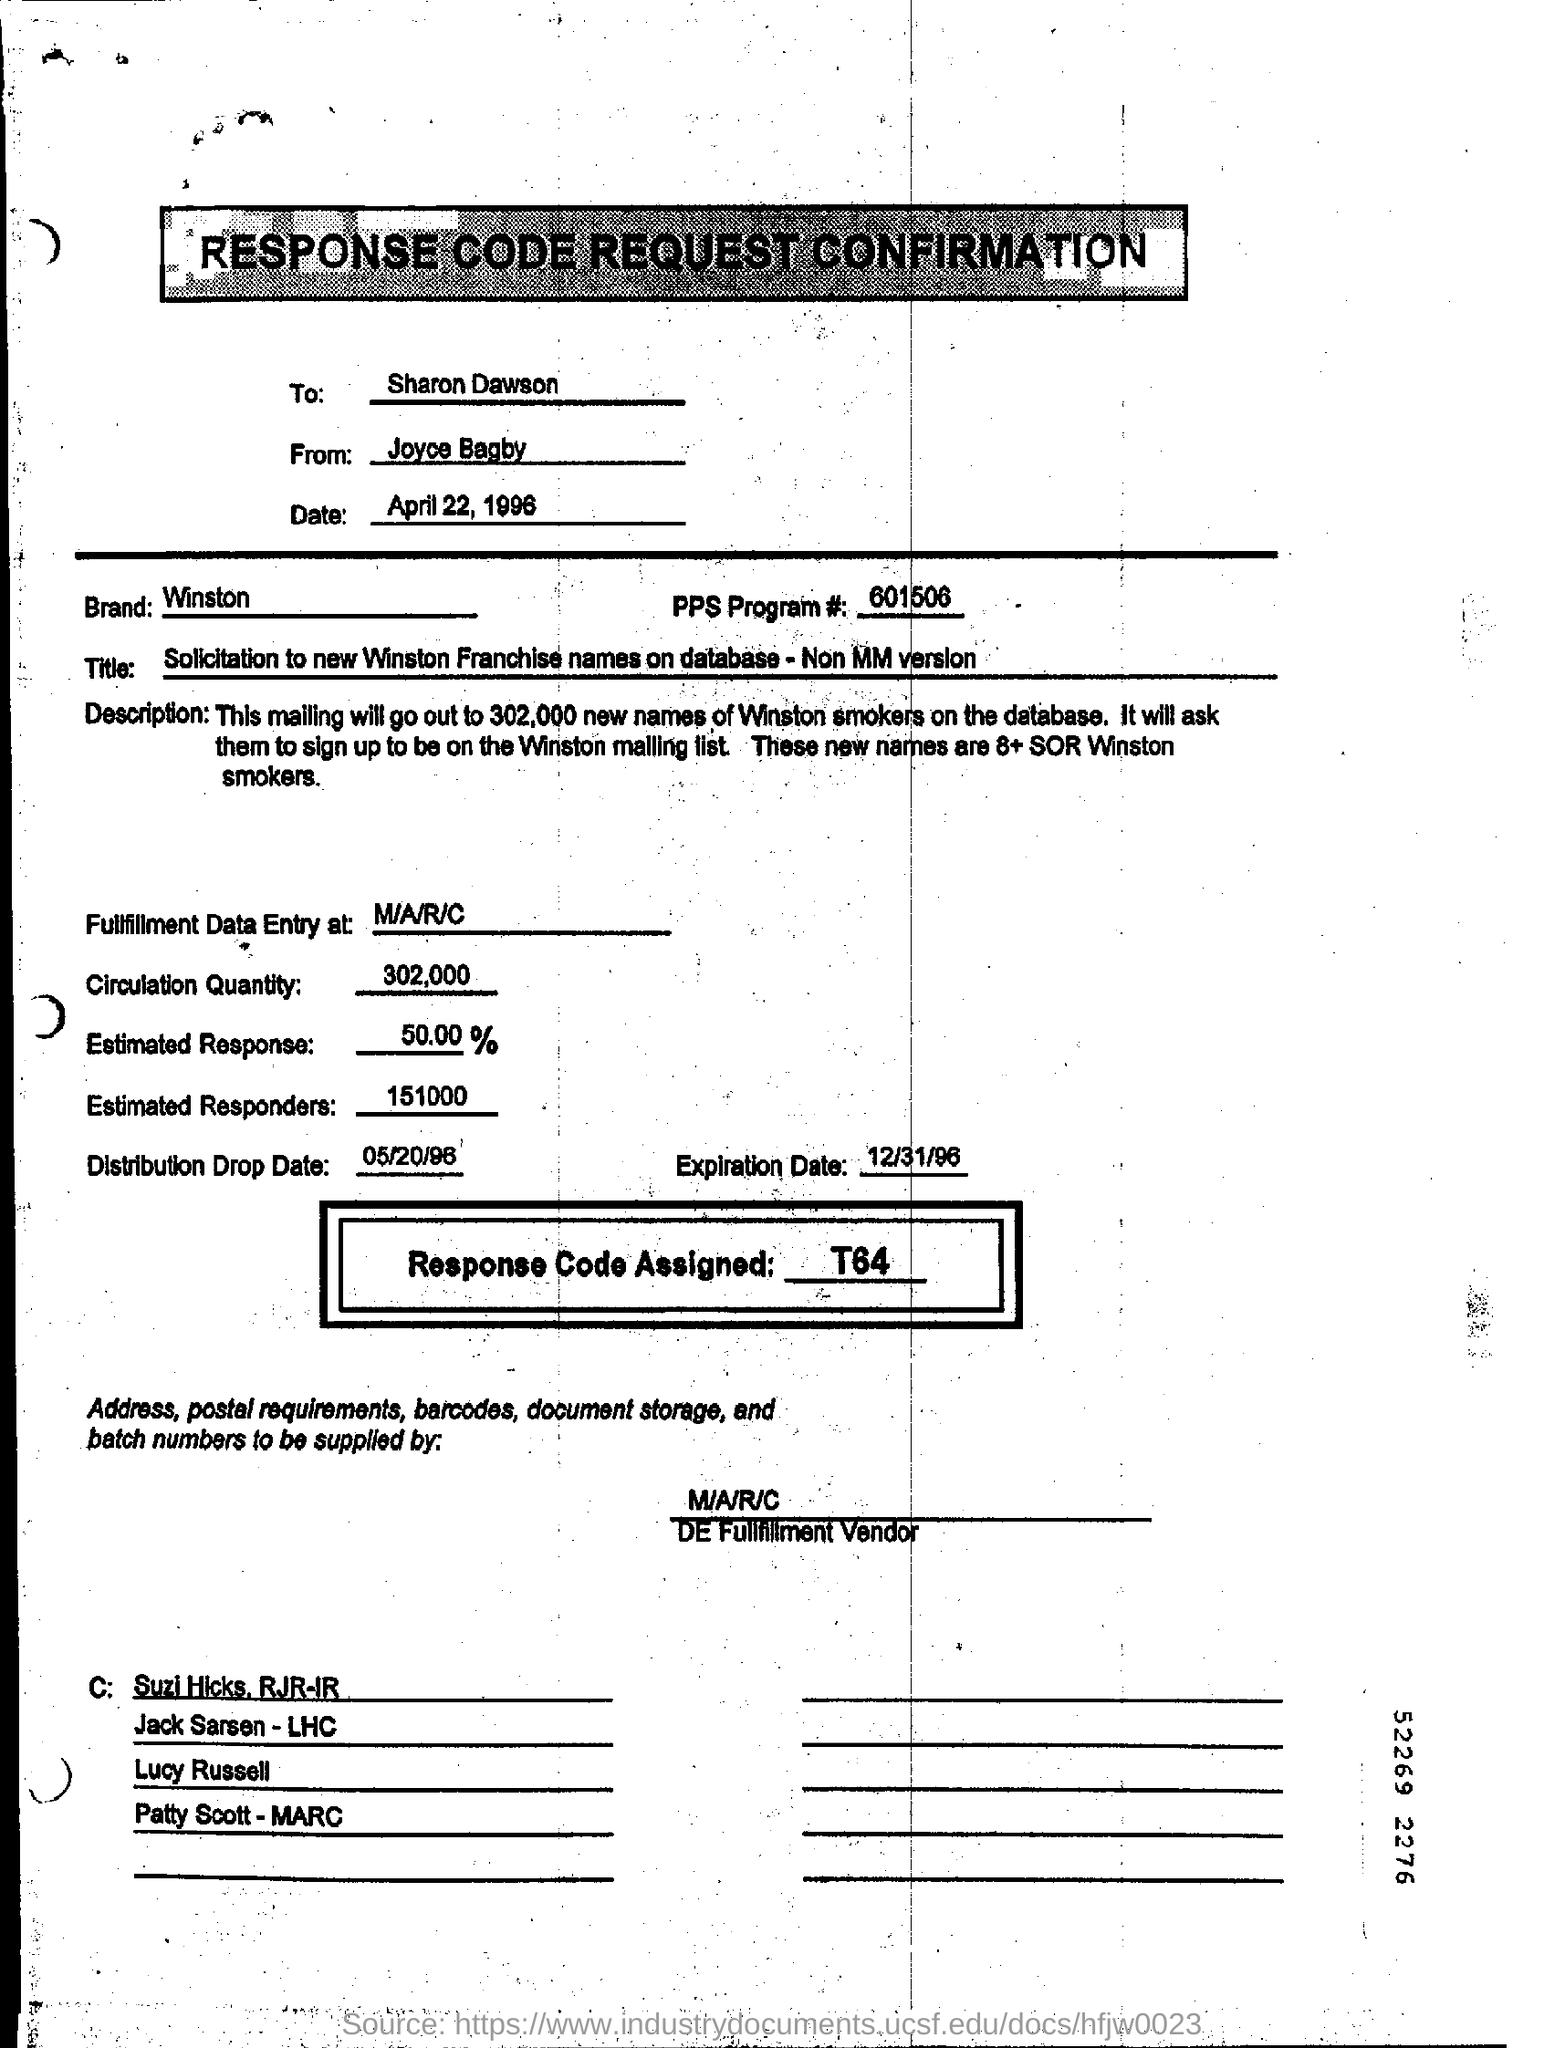Indicate a few pertinent items in this graphic. The circulation quantity is 302,000. The distribution drop date is May 20th, 1996. The code for the PPS program is 601506. The date in the "RESPONSE CODE REQUEST CONFIRMATION" is April 22, 1996. 